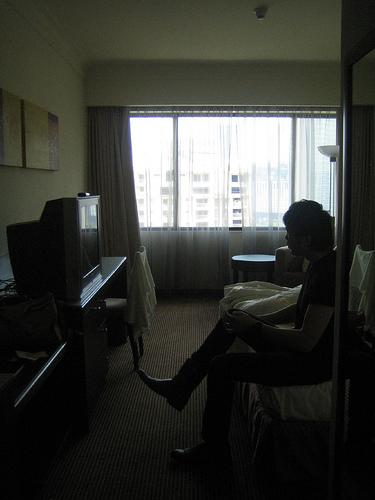Where is the woman sitting in? bed 